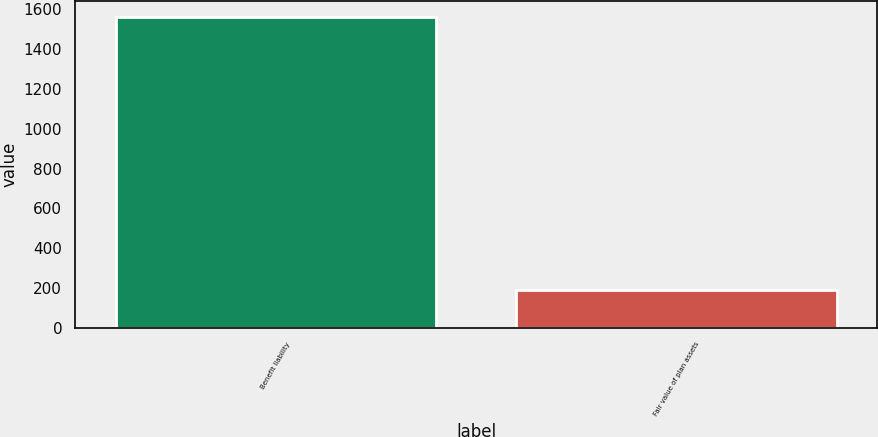<chart> <loc_0><loc_0><loc_500><loc_500><bar_chart><fcel>Benefit liability<fcel>Fair value of plan assets<nl><fcel>1563<fcel>190<nl></chart> 